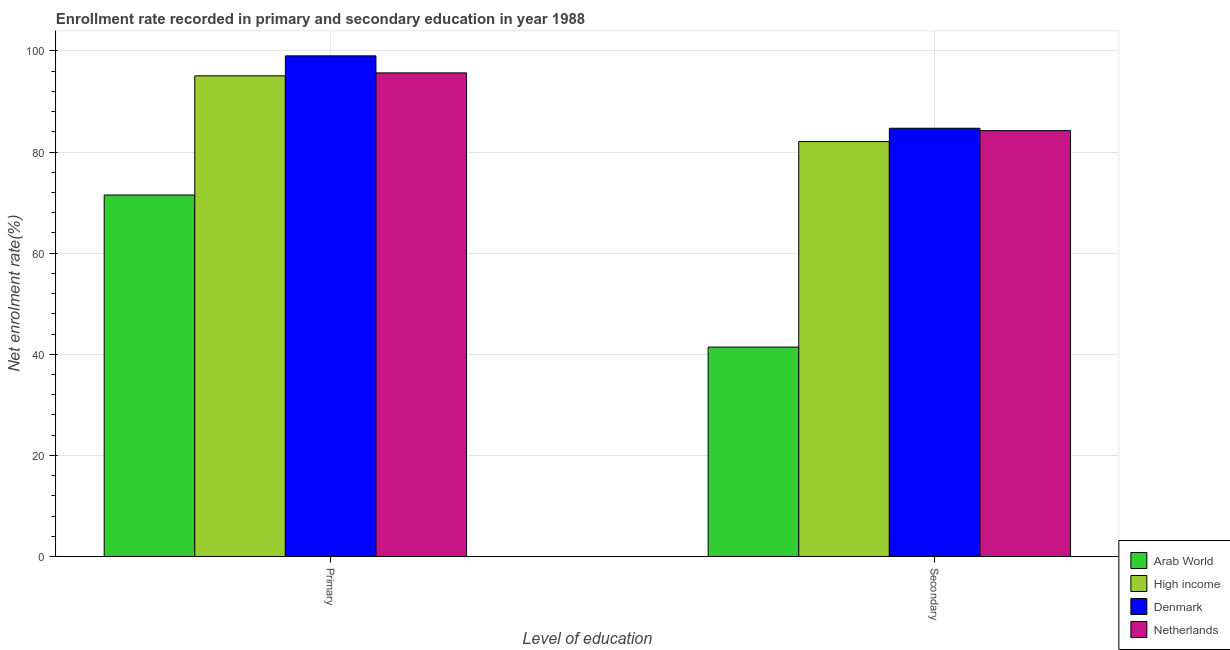How many different coloured bars are there?
Your answer should be very brief. 4. Are the number of bars on each tick of the X-axis equal?
Offer a terse response. Yes. How many bars are there on the 2nd tick from the left?
Your answer should be very brief. 4. How many bars are there on the 2nd tick from the right?
Your answer should be very brief. 4. What is the label of the 2nd group of bars from the left?
Offer a terse response. Secondary. What is the enrollment rate in secondary education in Netherlands?
Give a very brief answer. 84.25. Across all countries, what is the maximum enrollment rate in primary education?
Your response must be concise. 99.04. Across all countries, what is the minimum enrollment rate in secondary education?
Make the answer very short. 41.43. In which country was the enrollment rate in primary education minimum?
Give a very brief answer. Arab World. What is the total enrollment rate in primary education in the graph?
Make the answer very short. 361.3. What is the difference between the enrollment rate in primary education in Netherlands and that in Arab World?
Your answer should be compact. 24.16. What is the difference between the enrollment rate in primary education in Arab World and the enrollment rate in secondary education in High income?
Make the answer very short. -10.57. What is the average enrollment rate in secondary education per country?
Give a very brief answer. 73.12. What is the difference between the enrollment rate in secondary education and enrollment rate in primary education in High income?
Provide a succinct answer. -13. What is the ratio of the enrollment rate in primary education in Denmark to that in Arab World?
Your answer should be compact. 1.38. In how many countries, is the enrollment rate in secondary education greater than the average enrollment rate in secondary education taken over all countries?
Provide a short and direct response. 3. What does the 1st bar from the right in Secondary represents?
Offer a very short reply. Netherlands. How many bars are there?
Ensure brevity in your answer.  8. Are the values on the major ticks of Y-axis written in scientific E-notation?
Provide a succinct answer. No. Does the graph contain any zero values?
Your response must be concise. No. Does the graph contain grids?
Provide a succinct answer. Yes. Where does the legend appear in the graph?
Make the answer very short. Bottom right. What is the title of the graph?
Ensure brevity in your answer.  Enrollment rate recorded in primary and secondary education in year 1988. What is the label or title of the X-axis?
Your response must be concise. Level of education. What is the label or title of the Y-axis?
Your answer should be compact. Net enrolment rate(%). What is the Net enrolment rate(%) of Arab World in Primary?
Ensure brevity in your answer.  71.51. What is the Net enrolment rate(%) in High income in Primary?
Give a very brief answer. 95.08. What is the Net enrolment rate(%) of Denmark in Primary?
Provide a succinct answer. 99.04. What is the Net enrolment rate(%) in Netherlands in Primary?
Your answer should be very brief. 95.67. What is the Net enrolment rate(%) of Arab World in Secondary?
Your answer should be very brief. 41.43. What is the Net enrolment rate(%) of High income in Secondary?
Your answer should be compact. 82.08. What is the Net enrolment rate(%) in Denmark in Secondary?
Provide a short and direct response. 84.71. What is the Net enrolment rate(%) of Netherlands in Secondary?
Provide a succinct answer. 84.25. Across all Level of education, what is the maximum Net enrolment rate(%) in Arab World?
Your response must be concise. 71.51. Across all Level of education, what is the maximum Net enrolment rate(%) of High income?
Ensure brevity in your answer.  95.08. Across all Level of education, what is the maximum Net enrolment rate(%) in Denmark?
Keep it short and to the point. 99.04. Across all Level of education, what is the maximum Net enrolment rate(%) in Netherlands?
Provide a short and direct response. 95.67. Across all Level of education, what is the minimum Net enrolment rate(%) in Arab World?
Your answer should be very brief. 41.43. Across all Level of education, what is the minimum Net enrolment rate(%) of High income?
Keep it short and to the point. 82.08. Across all Level of education, what is the minimum Net enrolment rate(%) in Denmark?
Make the answer very short. 84.71. Across all Level of education, what is the minimum Net enrolment rate(%) in Netherlands?
Make the answer very short. 84.25. What is the total Net enrolment rate(%) of Arab World in the graph?
Provide a short and direct response. 112.94. What is the total Net enrolment rate(%) of High income in the graph?
Offer a very short reply. 177.17. What is the total Net enrolment rate(%) in Denmark in the graph?
Offer a very short reply. 183.75. What is the total Net enrolment rate(%) in Netherlands in the graph?
Make the answer very short. 179.92. What is the difference between the Net enrolment rate(%) of Arab World in Primary and that in Secondary?
Your response must be concise. 30.08. What is the difference between the Net enrolment rate(%) of High income in Primary and that in Secondary?
Your response must be concise. 13. What is the difference between the Net enrolment rate(%) in Denmark in Primary and that in Secondary?
Make the answer very short. 14.32. What is the difference between the Net enrolment rate(%) of Netherlands in Primary and that in Secondary?
Offer a terse response. 11.42. What is the difference between the Net enrolment rate(%) in Arab World in Primary and the Net enrolment rate(%) in High income in Secondary?
Your answer should be very brief. -10.57. What is the difference between the Net enrolment rate(%) of Arab World in Primary and the Net enrolment rate(%) of Denmark in Secondary?
Provide a short and direct response. -13.2. What is the difference between the Net enrolment rate(%) in Arab World in Primary and the Net enrolment rate(%) in Netherlands in Secondary?
Offer a terse response. -12.74. What is the difference between the Net enrolment rate(%) of High income in Primary and the Net enrolment rate(%) of Denmark in Secondary?
Your answer should be compact. 10.37. What is the difference between the Net enrolment rate(%) in High income in Primary and the Net enrolment rate(%) in Netherlands in Secondary?
Ensure brevity in your answer.  10.84. What is the difference between the Net enrolment rate(%) of Denmark in Primary and the Net enrolment rate(%) of Netherlands in Secondary?
Your response must be concise. 14.79. What is the average Net enrolment rate(%) in Arab World per Level of education?
Provide a short and direct response. 56.47. What is the average Net enrolment rate(%) in High income per Level of education?
Give a very brief answer. 88.58. What is the average Net enrolment rate(%) of Denmark per Level of education?
Offer a very short reply. 91.88. What is the average Net enrolment rate(%) of Netherlands per Level of education?
Your response must be concise. 89.96. What is the difference between the Net enrolment rate(%) in Arab World and Net enrolment rate(%) in High income in Primary?
Keep it short and to the point. -23.57. What is the difference between the Net enrolment rate(%) of Arab World and Net enrolment rate(%) of Denmark in Primary?
Your response must be concise. -27.53. What is the difference between the Net enrolment rate(%) in Arab World and Net enrolment rate(%) in Netherlands in Primary?
Give a very brief answer. -24.16. What is the difference between the Net enrolment rate(%) of High income and Net enrolment rate(%) of Denmark in Primary?
Make the answer very short. -3.95. What is the difference between the Net enrolment rate(%) of High income and Net enrolment rate(%) of Netherlands in Primary?
Provide a short and direct response. -0.58. What is the difference between the Net enrolment rate(%) of Denmark and Net enrolment rate(%) of Netherlands in Primary?
Provide a succinct answer. 3.37. What is the difference between the Net enrolment rate(%) of Arab World and Net enrolment rate(%) of High income in Secondary?
Give a very brief answer. -40.65. What is the difference between the Net enrolment rate(%) in Arab World and Net enrolment rate(%) in Denmark in Secondary?
Your answer should be very brief. -43.29. What is the difference between the Net enrolment rate(%) of Arab World and Net enrolment rate(%) of Netherlands in Secondary?
Your response must be concise. -42.82. What is the difference between the Net enrolment rate(%) in High income and Net enrolment rate(%) in Denmark in Secondary?
Keep it short and to the point. -2.63. What is the difference between the Net enrolment rate(%) in High income and Net enrolment rate(%) in Netherlands in Secondary?
Make the answer very short. -2.17. What is the difference between the Net enrolment rate(%) in Denmark and Net enrolment rate(%) in Netherlands in Secondary?
Provide a succinct answer. 0.47. What is the ratio of the Net enrolment rate(%) of Arab World in Primary to that in Secondary?
Provide a short and direct response. 1.73. What is the ratio of the Net enrolment rate(%) of High income in Primary to that in Secondary?
Give a very brief answer. 1.16. What is the ratio of the Net enrolment rate(%) in Denmark in Primary to that in Secondary?
Provide a short and direct response. 1.17. What is the ratio of the Net enrolment rate(%) of Netherlands in Primary to that in Secondary?
Make the answer very short. 1.14. What is the difference between the highest and the second highest Net enrolment rate(%) in Arab World?
Offer a very short reply. 30.08. What is the difference between the highest and the second highest Net enrolment rate(%) of High income?
Your answer should be very brief. 13. What is the difference between the highest and the second highest Net enrolment rate(%) in Denmark?
Your answer should be very brief. 14.32. What is the difference between the highest and the second highest Net enrolment rate(%) of Netherlands?
Provide a short and direct response. 11.42. What is the difference between the highest and the lowest Net enrolment rate(%) in Arab World?
Give a very brief answer. 30.08. What is the difference between the highest and the lowest Net enrolment rate(%) of High income?
Offer a terse response. 13. What is the difference between the highest and the lowest Net enrolment rate(%) of Denmark?
Provide a short and direct response. 14.32. What is the difference between the highest and the lowest Net enrolment rate(%) in Netherlands?
Provide a short and direct response. 11.42. 